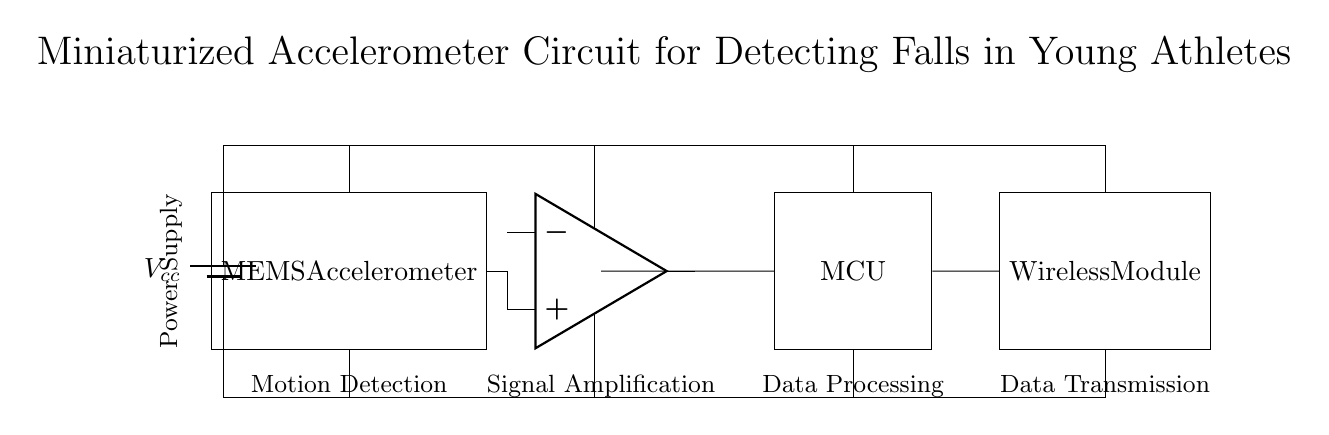What is the function of the MEMS accelerometer? The MEMS accelerometer detects motion, specifically the falls of young athletes, by measuring acceleration forces.
Answer: Motion Detection What component amplifies the signal from the accelerometer? The operational amplifier (op amp) is responsible for amplifying the signal received from the accelerometer to ensure it is strong enough for processing.
Answer: Operational amplifier How many main components are there in the circuit? The circuit consists of four main components: the accelerometer, the operational amplifier, the microcontroller, and the wireless module.
Answer: Four What devices are powered by the power supply? All components, including the MEMS accelerometer, operational amplifier, microcontroller, and wireless module, are powered by the power supply.
Answer: All components What is the purpose of the wireless module? The wireless module transmits the processed data wirelessly, allowing for real-time monitoring and alerting of falls.
Answer: Data Transmission How does the signal flow through the circuit? The signal flows from the MEMS accelerometer to the operational amplifier for amplification, then to the microcontroller for processing, and finally to the wireless module for transmission.
Answer: From accelerometer to op amp to microcontroller to wireless module What does MCU stand for in this circuit? MCU stands for Microcontroller Unit, which processes the amplified signals received from the operational amplifier.
Answer: Microcontroller Unit 